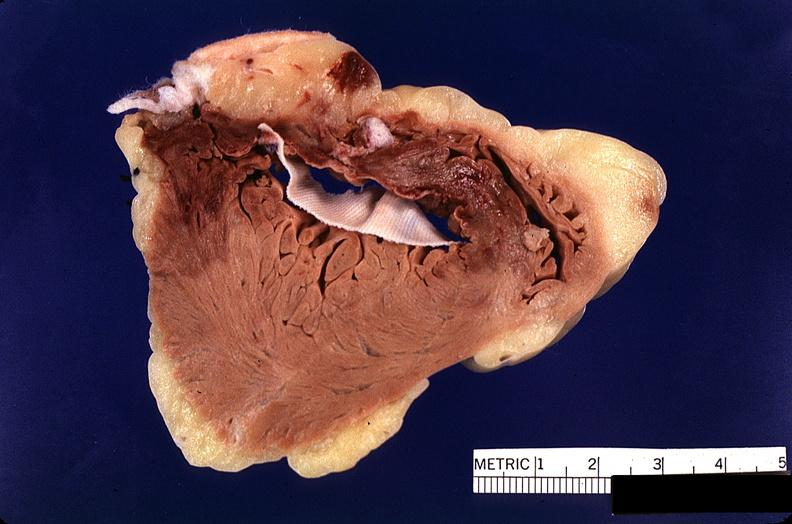what does this image show?
Answer the question using a single word or phrase. Heart 